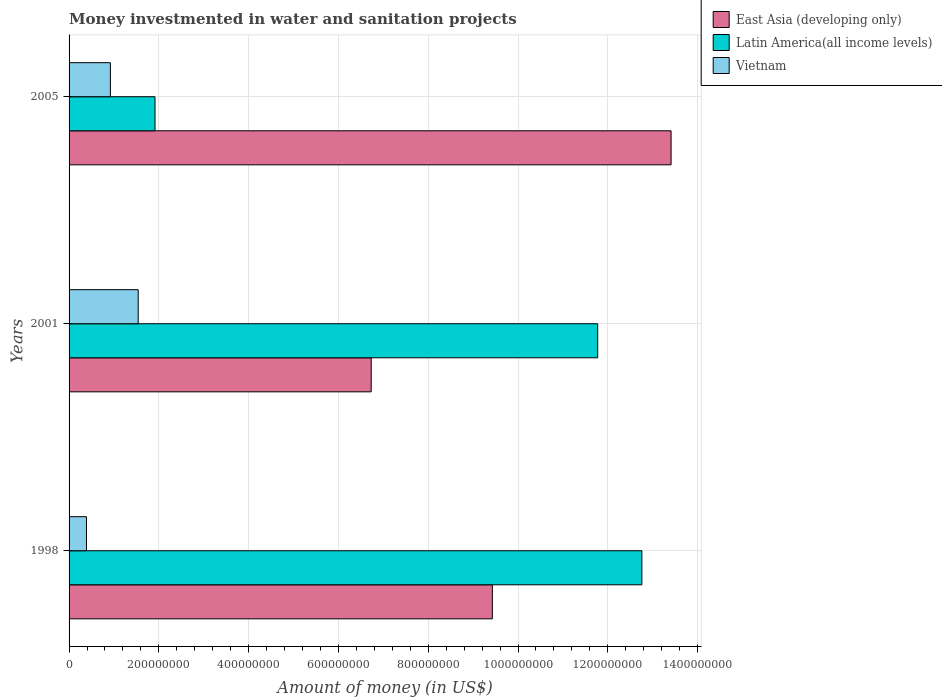How many groups of bars are there?
Your answer should be very brief. 3. Are the number of bars per tick equal to the number of legend labels?
Your answer should be compact. Yes. Are the number of bars on each tick of the Y-axis equal?
Give a very brief answer. Yes. How many bars are there on the 1st tick from the top?
Provide a short and direct response. 3. How many bars are there on the 1st tick from the bottom?
Provide a short and direct response. 3. What is the label of the 3rd group of bars from the top?
Offer a terse response. 1998. In how many cases, is the number of bars for a given year not equal to the number of legend labels?
Make the answer very short. 0. What is the money investmented in water and sanitation projects in Latin America(all income levels) in 1998?
Your answer should be very brief. 1.28e+09. Across all years, what is the maximum money investmented in water and sanitation projects in East Asia (developing only)?
Provide a short and direct response. 1.34e+09. Across all years, what is the minimum money investmented in water and sanitation projects in Latin America(all income levels)?
Your answer should be very brief. 1.91e+08. In which year was the money investmented in water and sanitation projects in Vietnam maximum?
Give a very brief answer. 2001. In which year was the money investmented in water and sanitation projects in East Asia (developing only) minimum?
Your answer should be compact. 2001. What is the total money investmented in water and sanitation projects in Latin America(all income levels) in the graph?
Your response must be concise. 2.64e+09. What is the difference between the money investmented in water and sanitation projects in Latin America(all income levels) in 1998 and that in 2005?
Offer a terse response. 1.08e+09. What is the difference between the money investmented in water and sanitation projects in Vietnam in 2005 and the money investmented in water and sanitation projects in Latin America(all income levels) in 2001?
Ensure brevity in your answer.  -1.09e+09. What is the average money investmented in water and sanitation projects in East Asia (developing only) per year?
Keep it short and to the point. 9.86e+08. In the year 1998, what is the difference between the money investmented in water and sanitation projects in Latin America(all income levels) and money investmented in water and sanitation projects in East Asia (developing only)?
Keep it short and to the point. 3.33e+08. What is the ratio of the money investmented in water and sanitation projects in East Asia (developing only) in 1998 to that in 2001?
Your answer should be very brief. 1.4. What is the difference between the highest and the second highest money investmented in water and sanitation projects in Latin America(all income levels)?
Your answer should be very brief. 9.85e+07. What is the difference between the highest and the lowest money investmented in water and sanitation projects in Latin America(all income levels)?
Your response must be concise. 1.08e+09. What does the 2nd bar from the top in 2001 represents?
Your answer should be compact. Latin America(all income levels). What does the 3rd bar from the bottom in 1998 represents?
Offer a very short reply. Vietnam. Is it the case that in every year, the sum of the money investmented in water and sanitation projects in Vietnam and money investmented in water and sanitation projects in East Asia (developing only) is greater than the money investmented in water and sanitation projects in Latin America(all income levels)?
Offer a very short reply. No. Are all the bars in the graph horizontal?
Keep it short and to the point. Yes. What is the difference between two consecutive major ticks on the X-axis?
Provide a short and direct response. 2.00e+08. Are the values on the major ticks of X-axis written in scientific E-notation?
Make the answer very short. No. Does the graph contain grids?
Make the answer very short. Yes. How many legend labels are there?
Ensure brevity in your answer.  3. What is the title of the graph?
Provide a succinct answer. Money investmented in water and sanitation projects. What is the label or title of the X-axis?
Provide a succinct answer. Amount of money (in US$). What is the label or title of the Y-axis?
Provide a short and direct response. Years. What is the Amount of money (in US$) of East Asia (developing only) in 1998?
Provide a succinct answer. 9.43e+08. What is the Amount of money (in US$) in Latin America(all income levels) in 1998?
Give a very brief answer. 1.28e+09. What is the Amount of money (in US$) in Vietnam in 1998?
Offer a very short reply. 3.88e+07. What is the Amount of money (in US$) of East Asia (developing only) in 2001?
Make the answer very short. 6.73e+08. What is the Amount of money (in US$) of Latin America(all income levels) in 2001?
Make the answer very short. 1.18e+09. What is the Amount of money (in US$) in Vietnam in 2001?
Offer a very short reply. 1.54e+08. What is the Amount of money (in US$) of East Asia (developing only) in 2005?
Ensure brevity in your answer.  1.34e+09. What is the Amount of money (in US$) of Latin America(all income levels) in 2005?
Offer a very short reply. 1.91e+08. What is the Amount of money (in US$) in Vietnam in 2005?
Offer a very short reply. 9.20e+07. Across all years, what is the maximum Amount of money (in US$) in East Asia (developing only)?
Your answer should be very brief. 1.34e+09. Across all years, what is the maximum Amount of money (in US$) in Latin America(all income levels)?
Provide a short and direct response. 1.28e+09. Across all years, what is the maximum Amount of money (in US$) in Vietnam?
Your answer should be very brief. 1.54e+08. Across all years, what is the minimum Amount of money (in US$) of East Asia (developing only)?
Offer a terse response. 6.73e+08. Across all years, what is the minimum Amount of money (in US$) in Latin America(all income levels)?
Your answer should be very brief. 1.91e+08. Across all years, what is the minimum Amount of money (in US$) in Vietnam?
Your answer should be compact. 3.88e+07. What is the total Amount of money (in US$) of East Asia (developing only) in the graph?
Provide a succinct answer. 2.96e+09. What is the total Amount of money (in US$) in Latin America(all income levels) in the graph?
Offer a terse response. 2.64e+09. What is the total Amount of money (in US$) in Vietnam in the graph?
Offer a very short reply. 2.85e+08. What is the difference between the Amount of money (in US$) of East Asia (developing only) in 1998 and that in 2001?
Provide a short and direct response. 2.70e+08. What is the difference between the Amount of money (in US$) of Latin America(all income levels) in 1998 and that in 2001?
Make the answer very short. 9.85e+07. What is the difference between the Amount of money (in US$) in Vietnam in 1998 and that in 2001?
Your answer should be very brief. -1.15e+08. What is the difference between the Amount of money (in US$) of East Asia (developing only) in 1998 and that in 2005?
Your response must be concise. -3.98e+08. What is the difference between the Amount of money (in US$) of Latin America(all income levels) in 1998 and that in 2005?
Offer a very short reply. 1.08e+09. What is the difference between the Amount of money (in US$) in Vietnam in 1998 and that in 2005?
Give a very brief answer. -5.32e+07. What is the difference between the Amount of money (in US$) of East Asia (developing only) in 2001 and that in 2005?
Keep it short and to the point. -6.68e+08. What is the difference between the Amount of money (in US$) in Latin America(all income levels) in 2001 and that in 2005?
Make the answer very short. 9.86e+08. What is the difference between the Amount of money (in US$) in Vietnam in 2001 and that in 2005?
Make the answer very short. 6.20e+07. What is the difference between the Amount of money (in US$) in East Asia (developing only) in 1998 and the Amount of money (in US$) in Latin America(all income levels) in 2001?
Your response must be concise. -2.35e+08. What is the difference between the Amount of money (in US$) in East Asia (developing only) in 1998 and the Amount of money (in US$) in Vietnam in 2001?
Your response must be concise. 7.89e+08. What is the difference between the Amount of money (in US$) of Latin America(all income levels) in 1998 and the Amount of money (in US$) of Vietnam in 2001?
Your response must be concise. 1.12e+09. What is the difference between the Amount of money (in US$) of East Asia (developing only) in 1998 and the Amount of money (in US$) of Latin America(all income levels) in 2005?
Your answer should be very brief. 7.51e+08. What is the difference between the Amount of money (in US$) of East Asia (developing only) in 1998 and the Amount of money (in US$) of Vietnam in 2005?
Keep it short and to the point. 8.51e+08. What is the difference between the Amount of money (in US$) of Latin America(all income levels) in 1998 and the Amount of money (in US$) of Vietnam in 2005?
Provide a succinct answer. 1.18e+09. What is the difference between the Amount of money (in US$) of East Asia (developing only) in 2001 and the Amount of money (in US$) of Latin America(all income levels) in 2005?
Your answer should be compact. 4.82e+08. What is the difference between the Amount of money (in US$) in East Asia (developing only) in 2001 and the Amount of money (in US$) in Vietnam in 2005?
Your answer should be very brief. 5.81e+08. What is the difference between the Amount of money (in US$) of Latin America(all income levels) in 2001 and the Amount of money (in US$) of Vietnam in 2005?
Offer a terse response. 1.09e+09. What is the average Amount of money (in US$) of East Asia (developing only) per year?
Your response must be concise. 9.86e+08. What is the average Amount of money (in US$) of Latin America(all income levels) per year?
Offer a terse response. 8.82e+08. What is the average Amount of money (in US$) of Vietnam per year?
Provide a short and direct response. 9.49e+07. In the year 1998, what is the difference between the Amount of money (in US$) of East Asia (developing only) and Amount of money (in US$) of Latin America(all income levels)?
Offer a very short reply. -3.33e+08. In the year 1998, what is the difference between the Amount of money (in US$) of East Asia (developing only) and Amount of money (in US$) of Vietnam?
Provide a succinct answer. 9.04e+08. In the year 1998, what is the difference between the Amount of money (in US$) in Latin America(all income levels) and Amount of money (in US$) in Vietnam?
Your answer should be very brief. 1.24e+09. In the year 2001, what is the difference between the Amount of money (in US$) of East Asia (developing only) and Amount of money (in US$) of Latin America(all income levels)?
Ensure brevity in your answer.  -5.04e+08. In the year 2001, what is the difference between the Amount of money (in US$) in East Asia (developing only) and Amount of money (in US$) in Vietnam?
Give a very brief answer. 5.19e+08. In the year 2001, what is the difference between the Amount of money (in US$) in Latin America(all income levels) and Amount of money (in US$) in Vietnam?
Offer a terse response. 1.02e+09. In the year 2005, what is the difference between the Amount of money (in US$) in East Asia (developing only) and Amount of money (in US$) in Latin America(all income levels)?
Offer a very short reply. 1.15e+09. In the year 2005, what is the difference between the Amount of money (in US$) in East Asia (developing only) and Amount of money (in US$) in Vietnam?
Ensure brevity in your answer.  1.25e+09. In the year 2005, what is the difference between the Amount of money (in US$) of Latin America(all income levels) and Amount of money (in US$) of Vietnam?
Ensure brevity in your answer.  9.94e+07. What is the ratio of the Amount of money (in US$) in East Asia (developing only) in 1998 to that in 2001?
Make the answer very short. 1.4. What is the ratio of the Amount of money (in US$) in Latin America(all income levels) in 1998 to that in 2001?
Provide a succinct answer. 1.08. What is the ratio of the Amount of money (in US$) in Vietnam in 1998 to that in 2001?
Your answer should be very brief. 0.25. What is the ratio of the Amount of money (in US$) of East Asia (developing only) in 1998 to that in 2005?
Offer a very short reply. 0.7. What is the ratio of the Amount of money (in US$) of Latin America(all income levels) in 1998 to that in 2005?
Your answer should be compact. 6.66. What is the ratio of the Amount of money (in US$) in Vietnam in 1998 to that in 2005?
Make the answer very short. 0.42. What is the ratio of the Amount of money (in US$) in East Asia (developing only) in 2001 to that in 2005?
Keep it short and to the point. 0.5. What is the ratio of the Amount of money (in US$) of Latin America(all income levels) in 2001 to that in 2005?
Make the answer very short. 6.15. What is the ratio of the Amount of money (in US$) in Vietnam in 2001 to that in 2005?
Give a very brief answer. 1.67. What is the difference between the highest and the second highest Amount of money (in US$) of East Asia (developing only)?
Provide a short and direct response. 3.98e+08. What is the difference between the highest and the second highest Amount of money (in US$) in Latin America(all income levels)?
Ensure brevity in your answer.  9.85e+07. What is the difference between the highest and the second highest Amount of money (in US$) of Vietnam?
Keep it short and to the point. 6.20e+07. What is the difference between the highest and the lowest Amount of money (in US$) in East Asia (developing only)?
Provide a succinct answer. 6.68e+08. What is the difference between the highest and the lowest Amount of money (in US$) in Latin America(all income levels)?
Offer a very short reply. 1.08e+09. What is the difference between the highest and the lowest Amount of money (in US$) in Vietnam?
Your answer should be very brief. 1.15e+08. 